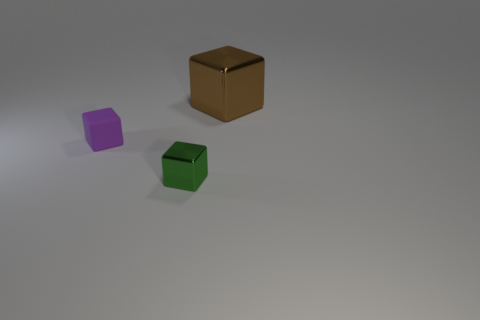Add 2 tiny metallic cubes. How many objects exist? 5 Subtract all small purple blocks. Subtract all small green rubber cylinders. How many objects are left? 2 Add 1 brown metal blocks. How many brown metal blocks are left? 2 Add 1 green shiny cylinders. How many green shiny cylinders exist? 1 Subtract 0 gray cylinders. How many objects are left? 3 